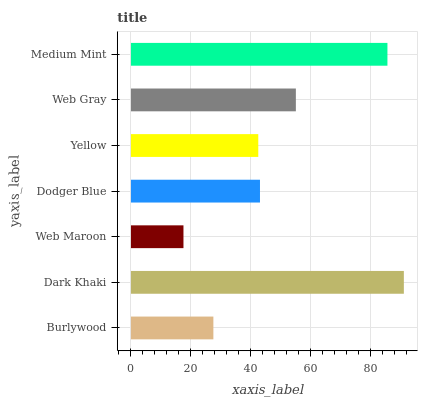Is Web Maroon the minimum?
Answer yes or no. Yes. Is Dark Khaki the maximum?
Answer yes or no. Yes. Is Dark Khaki the minimum?
Answer yes or no. No. Is Web Maroon the maximum?
Answer yes or no. No. Is Dark Khaki greater than Web Maroon?
Answer yes or no. Yes. Is Web Maroon less than Dark Khaki?
Answer yes or no. Yes. Is Web Maroon greater than Dark Khaki?
Answer yes or no. No. Is Dark Khaki less than Web Maroon?
Answer yes or no. No. Is Dodger Blue the high median?
Answer yes or no. Yes. Is Dodger Blue the low median?
Answer yes or no. Yes. Is Burlywood the high median?
Answer yes or no. No. Is Burlywood the low median?
Answer yes or no. No. 